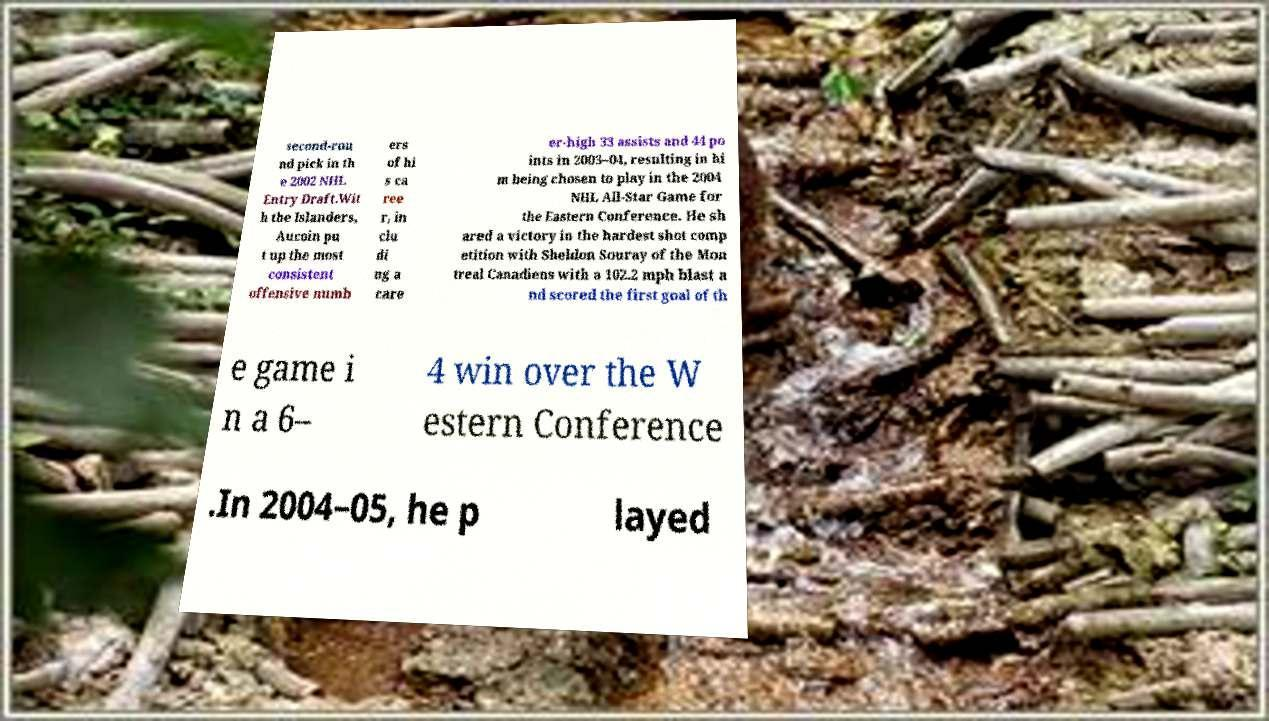What messages or text are displayed in this image? I need them in a readable, typed format. second-rou nd pick in th e 2002 NHL Entry Draft.Wit h the Islanders, Aucoin pu t up the most consistent offensive numb ers of hi s ca ree r, in clu di ng a care er-high 33 assists and 44 po ints in 2003–04, resulting in hi m being chosen to play in the 2004 NHL All-Star Game for the Eastern Conference. He sh ared a victory in the hardest shot comp etition with Sheldon Souray of the Mon treal Canadiens with a 102.2 mph blast a nd scored the first goal of th e game i n a 6– 4 win over the W estern Conference .In 2004–05, he p layed 